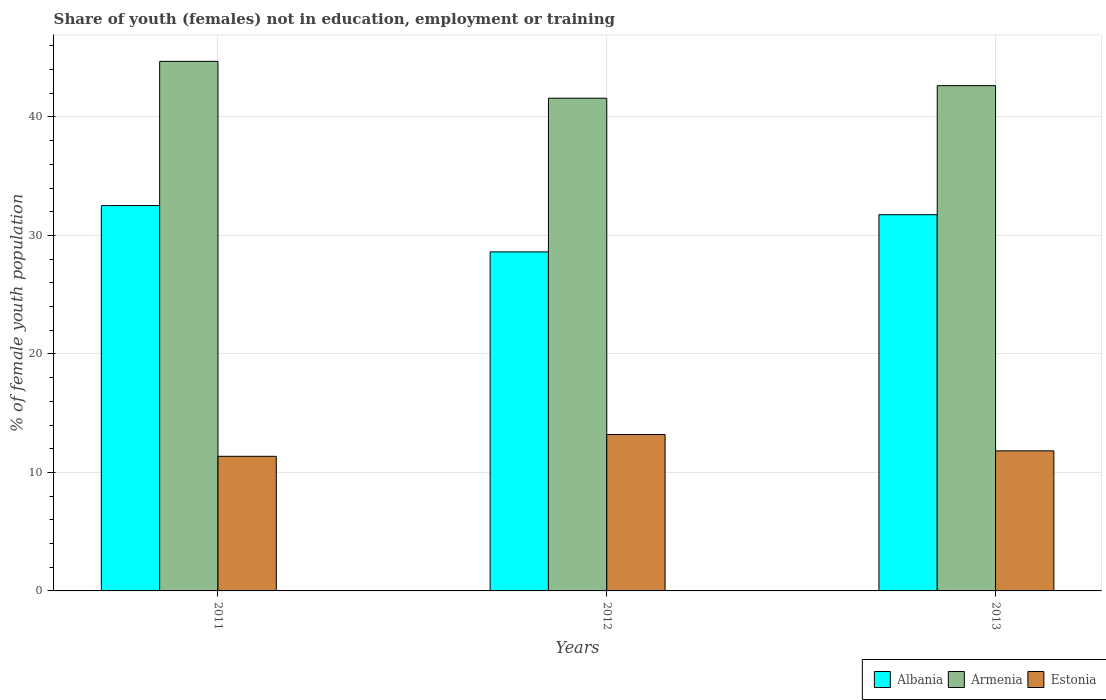How many different coloured bars are there?
Make the answer very short. 3. How many groups of bars are there?
Keep it short and to the point. 3. How many bars are there on the 3rd tick from the right?
Keep it short and to the point. 3. What is the label of the 1st group of bars from the left?
Provide a succinct answer. 2011. What is the percentage of unemployed female population in in Armenia in 2011?
Provide a short and direct response. 44.69. Across all years, what is the maximum percentage of unemployed female population in in Armenia?
Ensure brevity in your answer.  44.69. Across all years, what is the minimum percentage of unemployed female population in in Armenia?
Provide a succinct answer. 41.58. In which year was the percentage of unemployed female population in in Albania maximum?
Keep it short and to the point. 2011. In which year was the percentage of unemployed female population in in Estonia minimum?
Provide a succinct answer. 2011. What is the total percentage of unemployed female population in in Albania in the graph?
Offer a terse response. 92.88. What is the difference between the percentage of unemployed female population in in Estonia in 2011 and that in 2013?
Keep it short and to the point. -0.46. What is the difference between the percentage of unemployed female population in in Estonia in 2011 and the percentage of unemployed female population in in Albania in 2013?
Provide a succinct answer. -20.39. What is the average percentage of unemployed female population in in Albania per year?
Your response must be concise. 30.96. In the year 2012, what is the difference between the percentage of unemployed female population in in Estonia and percentage of unemployed female population in in Armenia?
Provide a short and direct response. -28.38. In how many years, is the percentage of unemployed female population in in Estonia greater than 32 %?
Your answer should be very brief. 0. What is the ratio of the percentage of unemployed female population in in Armenia in 2012 to that in 2013?
Offer a very short reply. 0.98. Is the percentage of unemployed female population in in Armenia in 2011 less than that in 2012?
Offer a very short reply. No. What is the difference between the highest and the second highest percentage of unemployed female population in in Armenia?
Give a very brief answer. 2.05. What is the difference between the highest and the lowest percentage of unemployed female population in in Albania?
Your answer should be very brief. 3.91. What does the 1st bar from the left in 2011 represents?
Provide a short and direct response. Albania. What does the 1st bar from the right in 2013 represents?
Give a very brief answer. Estonia. Is it the case that in every year, the sum of the percentage of unemployed female population in in Armenia and percentage of unemployed female population in in Estonia is greater than the percentage of unemployed female population in in Albania?
Offer a very short reply. Yes. How many bars are there?
Your response must be concise. 9. How many years are there in the graph?
Offer a terse response. 3. What is the difference between two consecutive major ticks on the Y-axis?
Your response must be concise. 10. Does the graph contain grids?
Provide a short and direct response. Yes. How many legend labels are there?
Your response must be concise. 3. How are the legend labels stacked?
Ensure brevity in your answer.  Horizontal. What is the title of the graph?
Provide a succinct answer. Share of youth (females) not in education, employment or training. Does "Mauritius" appear as one of the legend labels in the graph?
Provide a short and direct response. No. What is the label or title of the Y-axis?
Keep it short and to the point. % of female youth population. What is the % of female youth population of Albania in 2011?
Provide a succinct answer. 32.52. What is the % of female youth population in Armenia in 2011?
Provide a short and direct response. 44.69. What is the % of female youth population of Estonia in 2011?
Provide a short and direct response. 11.36. What is the % of female youth population of Albania in 2012?
Ensure brevity in your answer.  28.61. What is the % of female youth population of Armenia in 2012?
Your answer should be compact. 41.58. What is the % of female youth population in Estonia in 2012?
Offer a very short reply. 13.2. What is the % of female youth population in Albania in 2013?
Your answer should be very brief. 31.75. What is the % of female youth population in Armenia in 2013?
Provide a short and direct response. 42.64. What is the % of female youth population of Estonia in 2013?
Provide a succinct answer. 11.82. Across all years, what is the maximum % of female youth population of Albania?
Your response must be concise. 32.52. Across all years, what is the maximum % of female youth population in Armenia?
Provide a succinct answer. 44.69. Across all years, what is the maximum % of female youth population of Estonia?
Your response must be concise. 13.2. Across all years, what is the minimum % of female youth population of Albania?
Your response must be concise. 28.61. Across all years, what is the minimum % of female youth population of Armenia?
Offer a terse response. 41.58. Across all years, what is the minimum % of female youth population of Estonia?
Offer a terse response. 11.36. What is the total % of female youth population of Albania in the graph?
Give a very brief answer. 92.88. What is the total % of female youth population in Armenia in the graph?
Provide a succinct answer. 128.91. What is the total % of female youth population in Estonia in the graph?
Your answer should be compact. 36.38. What is the difference between the % of female youth population of Albania in 2011 and that in 2012?
Your response must be concise. 3.91. What is the difference between the % of female youth population in Armenia in 2011 and that in 2012?
Give a very brief answer. 3.11. What is the difference between the % of female youth population of Estonia in 2011 and that in 2012?
Provide a succinct answer. -1.84. What is the difference between the % of female youth population in Albania in 2011 and that in 2013?
Your answer should be very brief. 0.77. What is the difference between the % of female youth population of Armenia in 2011 and that in 2013?
Offer a terse response. 2.05. What is the difference between the % of female youth population in Estonia in 2011 and that in 2013?
Give a very brief answer. -0.46. What is the difference between the % of female youth population in Albania in 2012 and that in 2013?
Your answer should be very brief. -3.14. What is the difference between the % of female youth population of Armenia in 2012 and that in 2013?
Give a very brief answer. -1.06. What is the difference between the % of female youth population of Estonia in 2012 and that in 2013?
Offer a terse response. 1.38. What is the difference between the % of female youth population in Albania in 2011 and the % of female youth population in Armenia in 2012?
Give a very brief answer. -9.06. What is the difference between the % of female youth population of Albania in 2011 and the % of female youth population of Estonia in 2012?
Your answer should be compact. 19.32. What is the difference between the % of female youth population of Armenia in 2011 and the % of female youth population of Estonia in 2012?
Ensure brevity in your answer.  31.49. What is the difference between the % of female youth population of Albania in 2011 and the % of female youth population of Armenia in 2013?
Offer a very short reply. -10.12. What is the difference between the % of female youth population of Albania in 2011 and the % of female youth population of Estonia in 2013?
Ensure brevity in your answer.  20.7. What is the difference between the % of female youth population in Armenia in 2011 and the % of female youth population in Estonia in 2013?
Your answer should be compact. 32.87. What is the difference between the % of female youth population in Albania in 2012 and the % of female youth population in Armenia in 2013?
Give a very brief answer. -14.03. What is the difference between the % of female youth population of Albania in 2012 and the % of female youth population of Estonia in 2013?
Provide a short and direct response. 16.79. What is the difference between the % of female youth population of Armenia in 2012 and the % of female youth population of Estonia in 2013?
Your response must be concise. 29.76. What is the average % of female youth population of Albania per year?
Offer a terse response. 30.96. What is the average % of female youth population in Armenia per year?
Your answer should be very brief. 42.97. What is the average % of female youth population of Estonia per year?
Give a very brief answer. 12.13. In the year 2011, what is the difference between the % of female youth population of Albania and % of female youth population of Armenia?
Make the answer very short. -12.17. In the year 2011, what is the difference between the % of female youth population of Albania and % of female youth population of Estonia?
Your answer should be compact. 21.16. In the year 2011, what is the difference between the % of female youth population of Armenia and % of female youth population of Estonia?
Provide a short and direct response. 33.33. In the year 2012, what is the difference between the % of female youth population of Albania and % of female youth population of Armenia?
Provide a succinct answer. -12.97. In the year 2012, what is the difference between the % of female youth population of Albania and % of female youth population of Estonia?
Provide a succinct answer. 15.41. In the year 2012, what is the difference between the % of female youth population in Armenia and % of female youth population in Estonia?
Your answer should be very brief. 28.38. In the year 2013, what is the difference between the % of female youth population of Albania and % of female youth population of Armenia?
Keep it short and to the point. -10.89. In the year 2013, what is the difference between the % of female youth population of Albania and % of female youth population of Estonia?
Your answer should be compact. 19.93. In the year 2013, what is the difference between the % of female youth population of Armenia and % of female youth population of Estonia?
Make the answer very short. 30.82. What is the ratio of the % of female youth population of Albania in 2011 to that in 2012?
Make the answer very short. 1.14. What is the ratio of the % of female youth population in Armenia in 2011 to that in 2012?
Your answer should be compact. 1.07. What is the ratio of the % of female youth population of Estonia in 2011 to that in 2012?
Make the answer very short. 0.86. What is the ratio of the % of female youth population of Albania in 2011 to that in 2013?
Ensure brevity in your answer.  1.02. What is the ratio of the % of female youth population of Armenia in 2011 to that in 2013?
Provide a short and direct response. 1.05. What is the ratio of the % of female youth population in Estonia in 2011 to that in 2013?
Your answer should be compact. 0.96. What is the ratio of the % of female youth population in Albania in 2012 to that in 2013?
Keep it short and to the point. 0.9. What is the ratio of the % of female youth population in Armenia in 2012 to that in 2013?
Provide a short and direct response. 0.98. What is the ratio of the % of female youth population of Estonia in 2012 to that in 2013?
Offer a terse response. 1.12. What is the difference between the highest and the second highest % of female youth population in Albania?
Provide a short and direct response. 0.77. What is the difference between the highest and the second highest % of female youth population of Armenia?
Ensure brevity in your answer.  2.05. What is the difference between the highest and the second highest % of female youth population in Estonia?
Give a very brief answer. 1.38. What is the difference between the highest and the lowest % of female youth population in Albania?
Your answer should be very brief. 3.91. What is the difference between the highest and the lowest % of female youth population of Armenia?
Your answer should be compact. 3.11. What is the difference between the highest and the lowest % of female youth population of Estonia?
Provide a succinct answer. 1.84. 